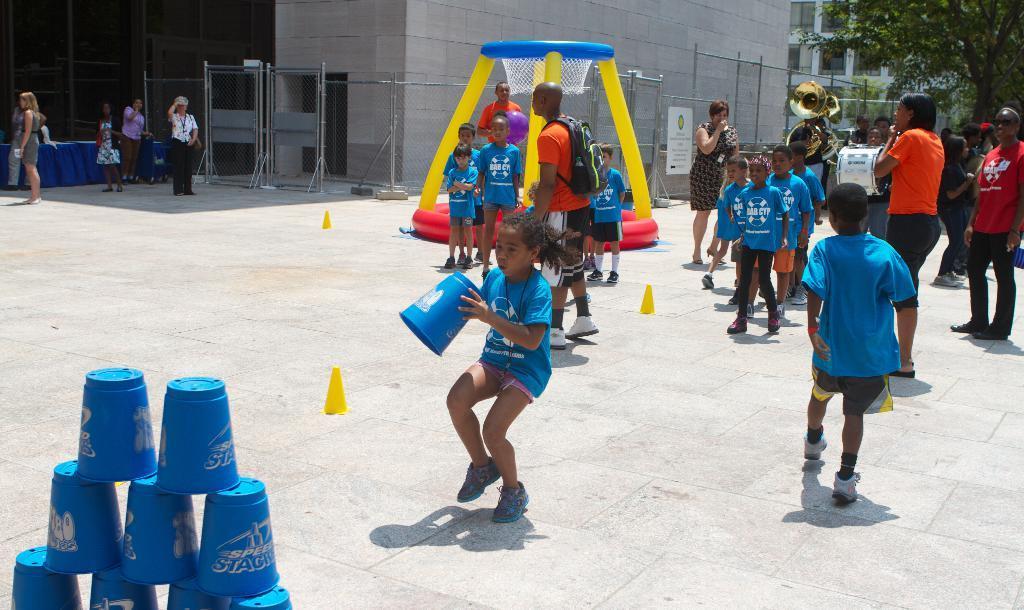In one or two sentences, can you explain what this image depicts? In this image I can see group of people, some are standing and some are walking. In front the person is wearing blue and brown color dress, and I can see few musical instruments. In front I can see few blue colored objects, background I can see a toy game in yellow and blue color. I can see trees in green color and the building is in gray color and I can see the railing. 